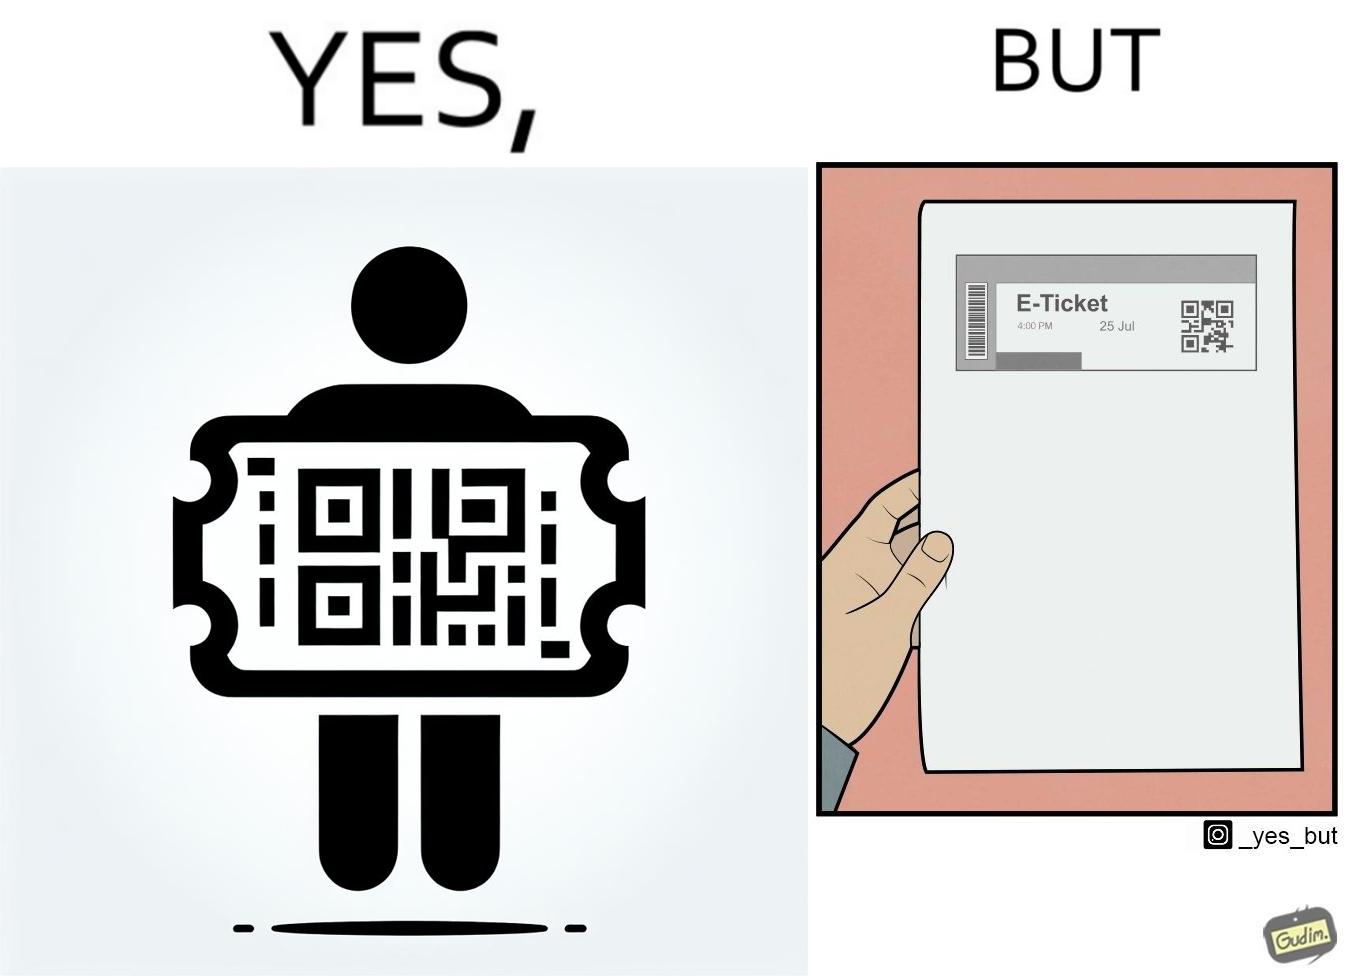Describe the content of this image. The images are ironic since even though e-tickets are provided to save resources like paper, people choose to print out e-tickets on large sheets of paper which leads to more wastage 